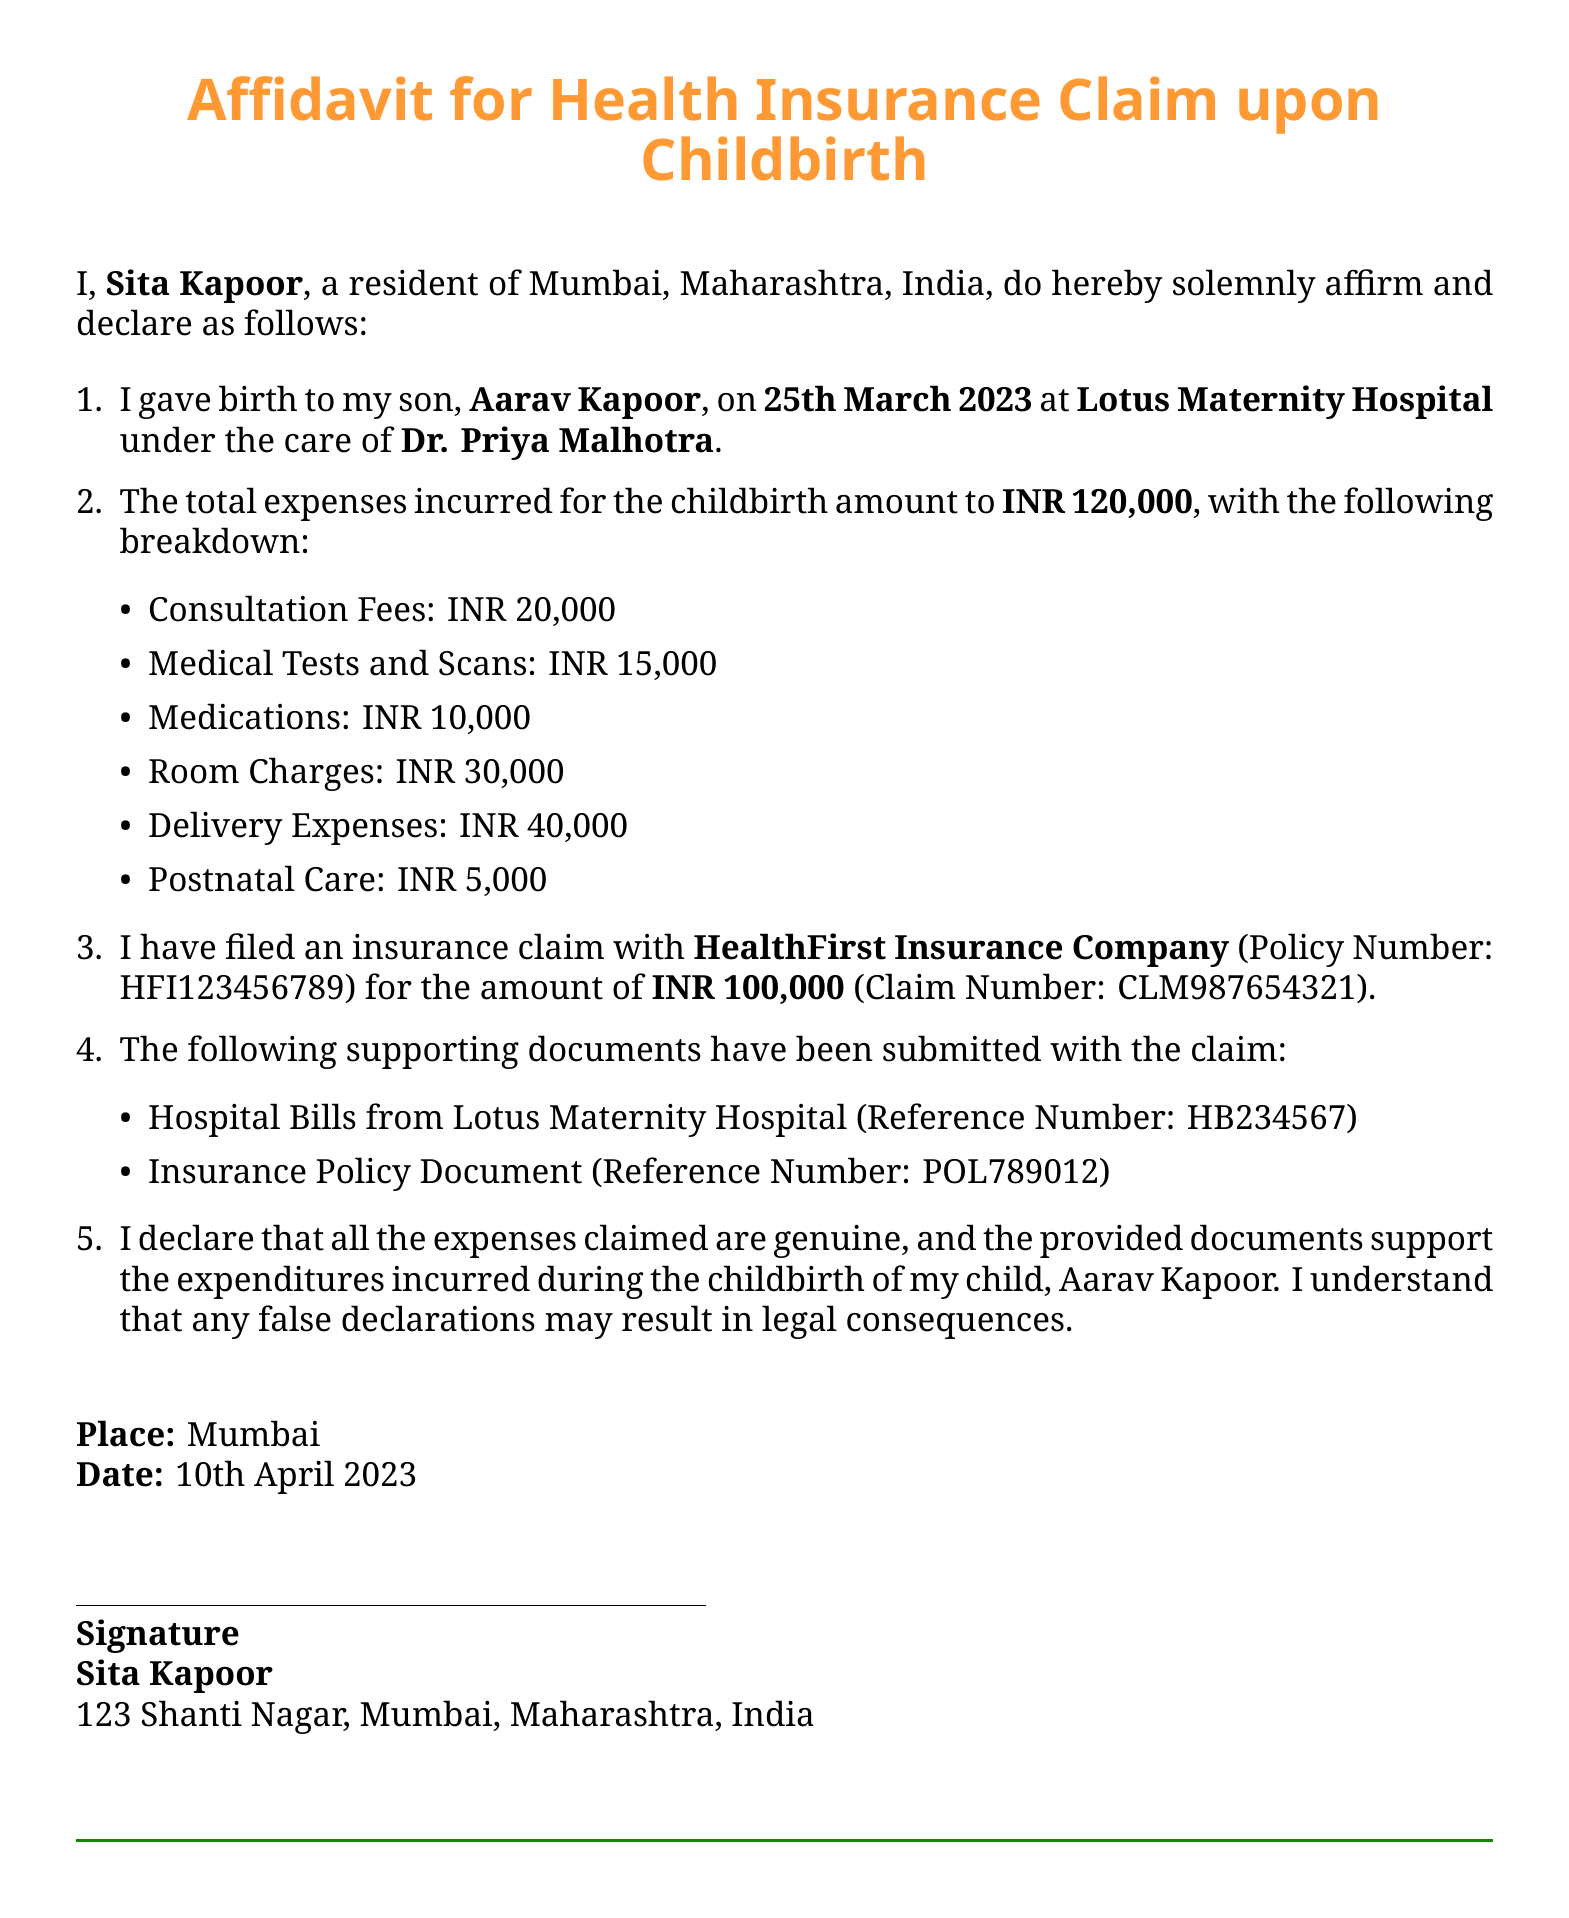What is the name of the individual making the affidavit? The affidavit is made by Sita Kapoor, who is identified as the individual affirming the document.
Answer: Sita Kapoor What is the date of childbirth mentioned in the affidavit? The affidavit states that the childbirth occurred on 25th March 2023.
Answer: 25th March 2023 What is the total amount of expenses incurred for childbirth? The document lists the total expenses incurred for childbirth as INR 120,000.
Answer: INR 120,000 What is the insurance claim amount filed with HealthFirst Insurance Company? The affidavit indicates that the claim amount filed is INR 100,000.
Answer: INR 100,000 What is the reference number for the hospital bills submitted? The supporting documents include a reference number for the hospital bills, which is HB234567.
Answer: HB234567 Who was the doctor that attended to the childbirth? The affidavit mentions that Dr. Priya Malhotra was the doctor who attended to the childbirth.
Answer: Dr. Priya Malhotra What is the insurance policy number provided in the document? The document specifies the insurance policy number as HFI123456789.
Answer: HFI123456789 What is the address of the individual making the affidavit? The address provided for Sita Kapoor is 123 Shanti Nagar, Mumbai, Maharashtra, India.
Answer: 123 Shanti Nagar, Mumbai, Maharashtra, India What type of medical expenses does the document specify? The affidavit details various expenses such as consultation fees, medical tests, and delivery expenses.
Answer: Consultation fees, medical tests, delivery expenses 